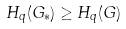Convert formula to latex. <formula><loc_0><loc_0><loc_500><loc_500>H _ { q } ( G _ { * } ) \geq H _ { q } ( G )</formula> 